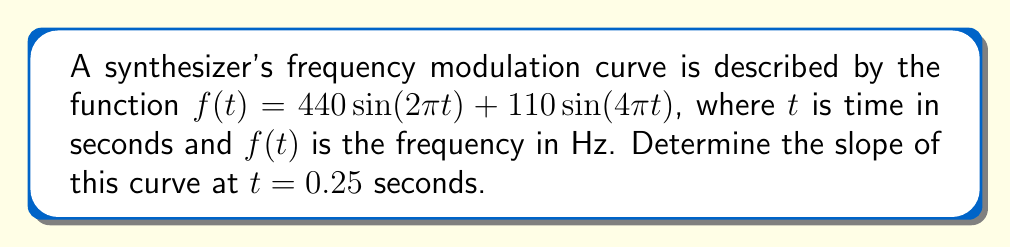What is the answer to this math problem? To find the slope of the curve at a specific point, we need to calculate the derivative of the function and evaluate it at the given point.

Step 1: Calculate the derivative of $f(t)$.
$$\begin{align}
f'(t) &= \frac{d}{dt}[440 \sin(2\pi t) + 110 \sin(4\pi t)] \\
&= 440 \cdot 2\pi \cos(2\pi t) + 110 \cdot 4\pi \cos(4\pi t) \\
&= 880\pi \cos(2\pi t) + 440\pi \cos(4\pi t)
\end{align}$$

Step 2: Evaluate $f'(t)$ at $t = 0.25$ seconds.
$$\begin{align}
f'(0.25) &= 880\pi \cos(2\pi \cdot 0.25) + 440\pi \cos(4\pi \cdot 0.25) \\
&= 880\pi \cos(\frac{\pi}{2}) + 440\pi \cos(\pi) \\
&= 880\pi \cdot 0 + 440\pi \cdot (-1) \\
&= -440\pi
\end{align}$$

The slope of the frequency modulation curve at $t = 0.25$ seconds is $-440\pi$ Hz/s.
Answer: $-440\pi$ Hz/s 